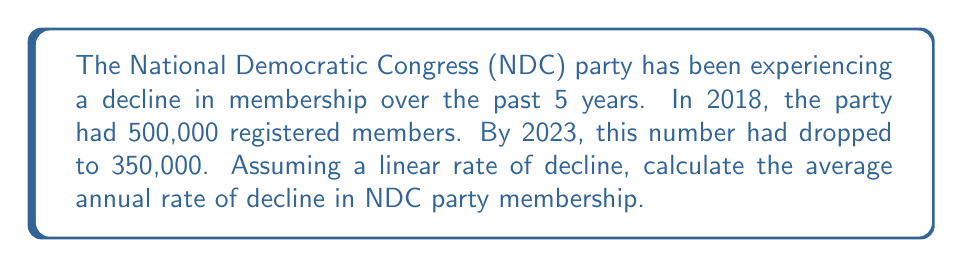Show me your answer to this math problem. To solve this problem, we'll follow these steps:

1. Calculate the total decline in membership:
   $$\text{Total decline} = 500,000 - 350,000 = 150,000\text{ members}$$

2. Determine the time period:
   $$\text{Time period} = 2023 - 2018 = 5\text{ years}$$

3. Calculate the average annual rate of decline:
   $$\text{Annual rate of decline} = \frac{\text{Total decline}}{\text{Time period}}$$
   
   $$\text{Annual rate of decline} = \frac{150,000}{5} = 30,000\text{ members per year}$$

4. To express this as a percentage of the initial membership:
   $$\text{Percentage decline} = \frac{\text{Annual rate of decline}}{\text{Initial membership}} \times 100\%$$
   
   $$\text{Percentage decline} = \frac{30,000}{500,000} \times 100\% = 6\%\text{ per year}$$

Therefore, the NDC party membership has been declining at an average rate of 30,000 members or 6% per year over the past 5 years.
Answer: 30,000 members or 6% per year 